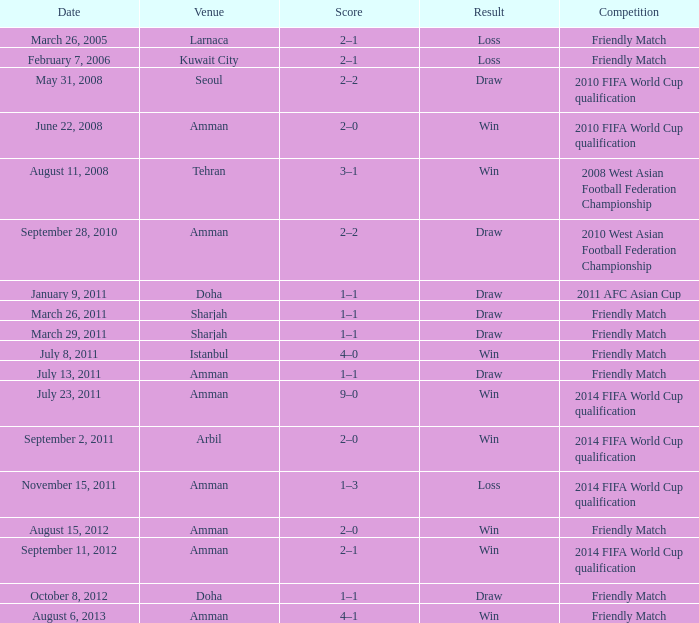What was the outcome of the friendly game that took place on october 8, 2012? Draw. 